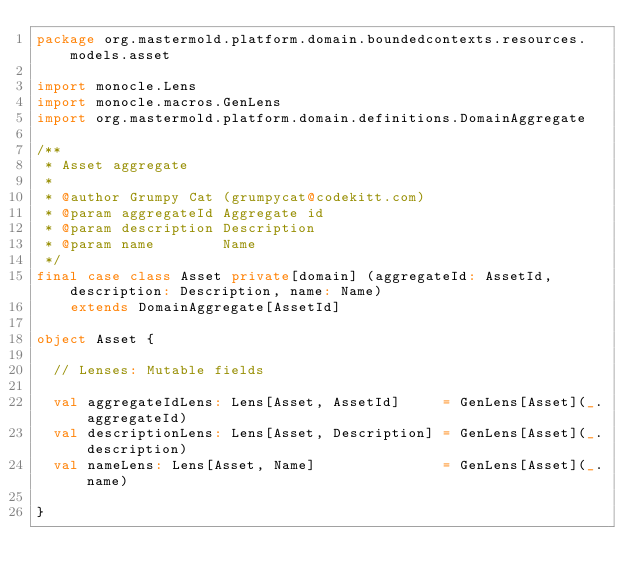<code> <loc_0><loc_0><loc_500><loc_500><_Scala_>package org.mastermold.platform.domain.boundedcontexts.resources.models.asset

import monocle.Lens
import monocle.macros.GenLens
import org.mastermold.platform.domain.definitions.DomainAggregate

/**
 * Asset aggregate
 *
 * @author Grumpy Cat (grumpycat@codekitt.com)
 * @param aggregateId Aggregate id
 * @param description Description
 * @param name        Name
 */
final case class Asset private[domain] (aggregateId: AssetId, description: Description, name: Name)
    extends DomainAggregate[AssetId]

object Asset {

  // Lenses: Mutable fields

  val aggregateIdLens: Lens[Asset, AssetId]     = GenLens[Asset](_.aggregateId)
  val descriptionLens: Lens[Asset, Description] = GenLens[Asset](_.description)
  val nameLens: Lens[Asset, Name]               = GenLens[Asset](_.name)

}
</code> 